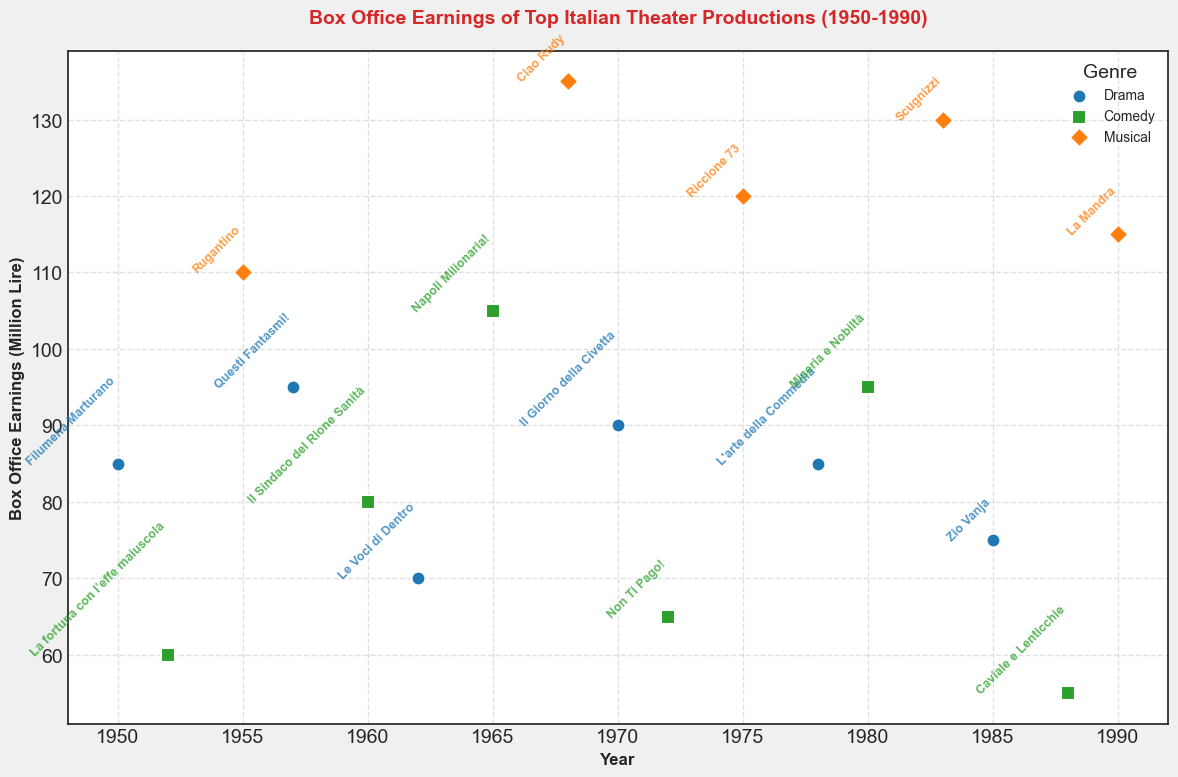Which genre has the highest box office earnings in a single production? To find which genre has the highest box office earnings, look for the highest value on the y-axis and identify its corresponding genre. "Ciao Rudy," a musical, has the highest earnings at 135 million lire.
Answer: Musical Which drama production has the lowest box office earnings, and what is the value? Identify all the drama productions (blue markers) and find the one with the lowest position on the y-axis. "Le Voci di Dentro" has the lowest drama box office earnings at 70 million lire.
Answer: Le Voci di Dentro, 70 Which year had the highest box office earnings for a comedy production, and what was the title? Locate the green markers (comedies) and find the highest position on the y-axis. For comedies, the highest earnings were in 1965 with "Napoli Milionaria!" at 105 million lire.
Answer: 1965, Napoli Milionaria! How much more did "Rugantino" earn compared to "Filumena Marturano"? First, find the box office earnings for "Rugantino" (a musical, 110 million lire) and "Filumena Marturano" (a drama, 85 million lire). Calculate the difference (110 - 85).
Answer: 25 million lire How many productions exceeded 100 million lire in box office earnings? Identify all the productions with earnings greater than 100 million lire by looking for points above this threshold on the y-axis. There are 5 such productions: "Ciao Rudy," "Riccione 73," "Scugnizzi," "La Mandra," and "Napoli Milionaria!"
Answer: 5 What is the average box office earnings of musical productions? Sum the box office earnings of all musical productions: 110 (Rugantino) + 135 (Ciao Rudy) + 120 (Riccione 73) + 130 (Scugnizzi) + 115 (La Mandra) = 610 million lire. Divide this by the number of musicals (5).
Answer: 122 million lire Which production has the highest earnings in the 1970s, and what genre is it? Look at productions from the 1970s and identify the one with the highest position on the y-axis. "Riccione 73," a musical in 1975, has the highest earnings at 120 million lire.
Answer: Riccione 73, Musical What is the difference in box office earnings between the highest and lowest earning productions in each genre? - For drama, the highest is "Questi Fantasmi!" (95) and the lowest is "Le Voci di Dentro" (70). Difference: 95 - 70 = 25 million lire.
- For comedy, the highest is "Napoli Milionaria!" (105) and the lowest is "Caviale e Lenticchie" (55). Difference: 105 - 55 = 50 million lire.
- For musical, the highest is "Ciao Rudy" (135) and the lowest is "Rugantino" (110). Difference: 135 - 110 = 25 million lire.
Answer: Drama: 25, Comedy: 50, Musical: 25 Looking at trends, which decade saw the highest box office earnings for musical productions overall? Sum the earnings for musicals in each decade and compare:
- 1950s: 110 (Rugantino) = 110
- 1960s: 135 (Ciao Rudy) = 135
- 1970s: 120 (Riccione 73) = 120
- 1980s: 130 (Scugnizzi) + 115 (La Mandra) = 245
The 1980s saw the highest total earnings.
Answer: 1980s How many productions earned between 70 and 90 million lire? Identify productions based on their y-axis value that lies between 70 and 90 million lire. They are "Filumena Marturano," "Il Giorno della Civetta," "Zio Vanja," "Le Voci di Dentro," "Non Ti Pago!," and "L'arte della Commedia." There are 6 productions in this range.
Answer: 6 